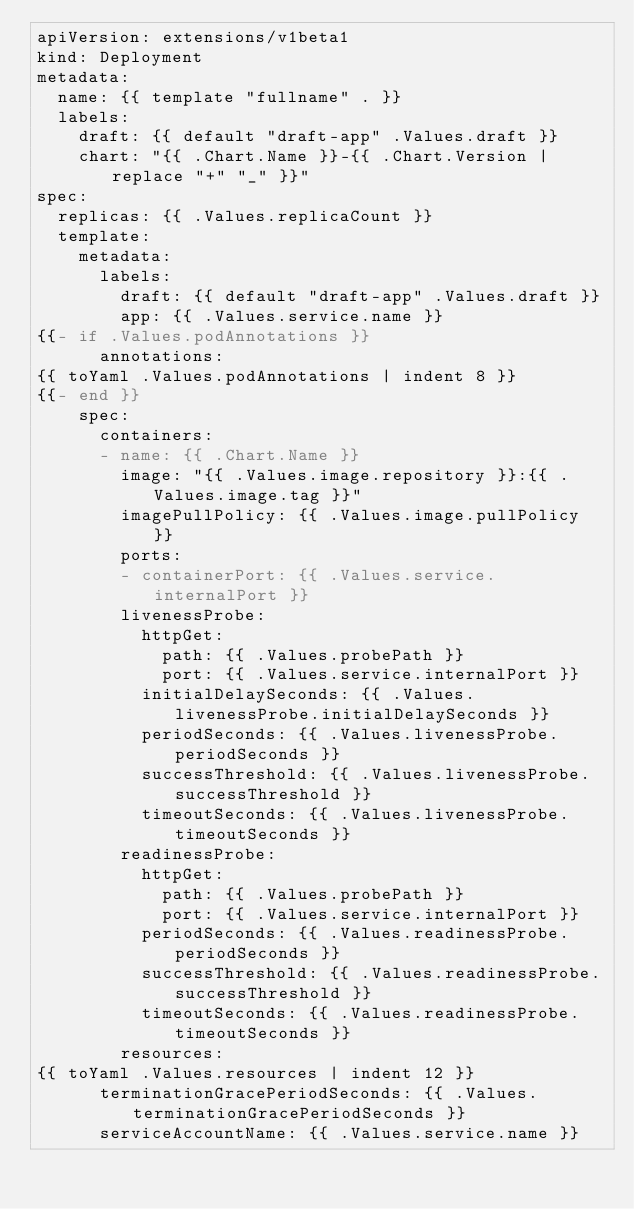<code> <loc_0><loc_0><loc_500><loc_500><_YAML_>apiVersion: extensions/v1beta1
kind: Deployment
metadata:
  name: {{ template "fullname" . }}
  labels:
    draft: {{ default "draft-app" .Values.draft }}
    chart: "{{ .Chart.Name }}-{{ .Chart.Version | replace "+" "_" }}"
spec:
  replicas: {{ .Values.replicaCount }}
  template:
    metadata:
      labels:
        draft: {{ default "draft-app" .Values.draft }}
        app: {{ .Values.service.name }}
{{- if .Values.podAnnotations }}
      annotations:
{{ toYaml .Values.podAnnotations | indent 8 }}
{{- end }}
    spec:
      containers:
      - name: {{ .Chart.Name }}
        image: "{{ .Values.image.repository }}:{{ .Values.image.tag }}"
        imagePullPolicy: {{ .Values.image.pullPolicy }}
        ports:
        - containerPort: {{ .Values.service.internalPort }}
        livenessProbe:
          httpGet:
            path: {{ .Values.probePath }}
            port: {{ .Values.service.internalPort }}
          initialDelaySeconds: {{ .Values.livenessProbe.initialDelaySeconds }}
          periodSeconds: {{ .Values.livenessProbe.periodSeconds }}
          successThreshold: {{ .Values.livenessProbe.successThreshold }}
          timeoutSeconds: {{ .Values.livenessProbe.timeoutSeconds }}
        readinessProbe:
          httpGet:
            path: {{ .Values.probePath }}
            port: {{ .Values.service.internalPort }}
          periodSeconds: {{ .Values.readinessProbe.periodSeconds }}
          successThreshold: {{ .Values.readinessProbe.successThreshold }}
          timeoutSeconds: {{ .Values.readinessProbe.timeoutSeconds }}
        resources:
{{ toYaml .Values.resources | indent 12 }}
      terminationGracePeriodSeconds: {{ .Values.terminationGracePeriodSeconds }}
      serviceAccountName: {{ .Values.service.name }}</code> 